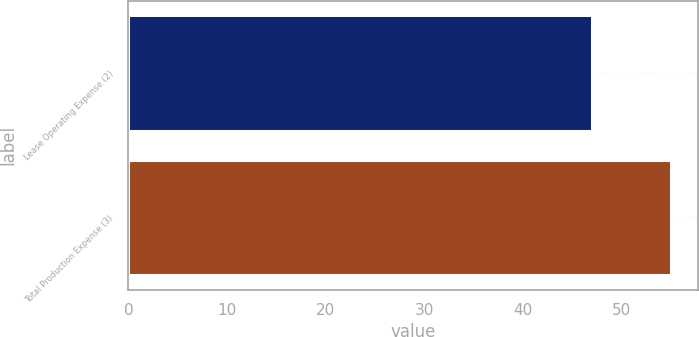Convert chart to OTSL. <chart><loc_0><loc_0><loc_500><loc_500><bar_chart><fcel>Lease Operating Expense (2)<fcel>Total Production Expense (3)<nl><fcel>47<fcel>55<nl></chart> 